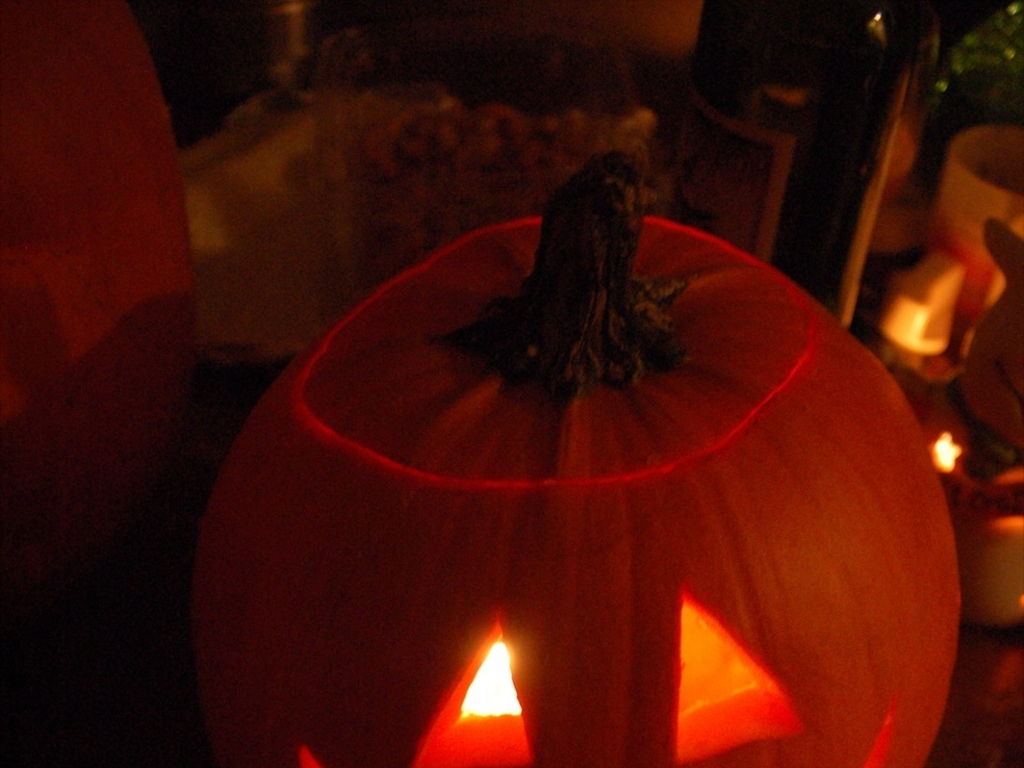Can you describe any details in the background of the image? The background of the image is steeped in shadows, hinting at the presence of other objects that meld into the darkness. There appears to be a bottle and possibly some containers, suggesting that the pumpkin lantern may be part of a larger decorative setup or a gathering where food and drinks are present. 